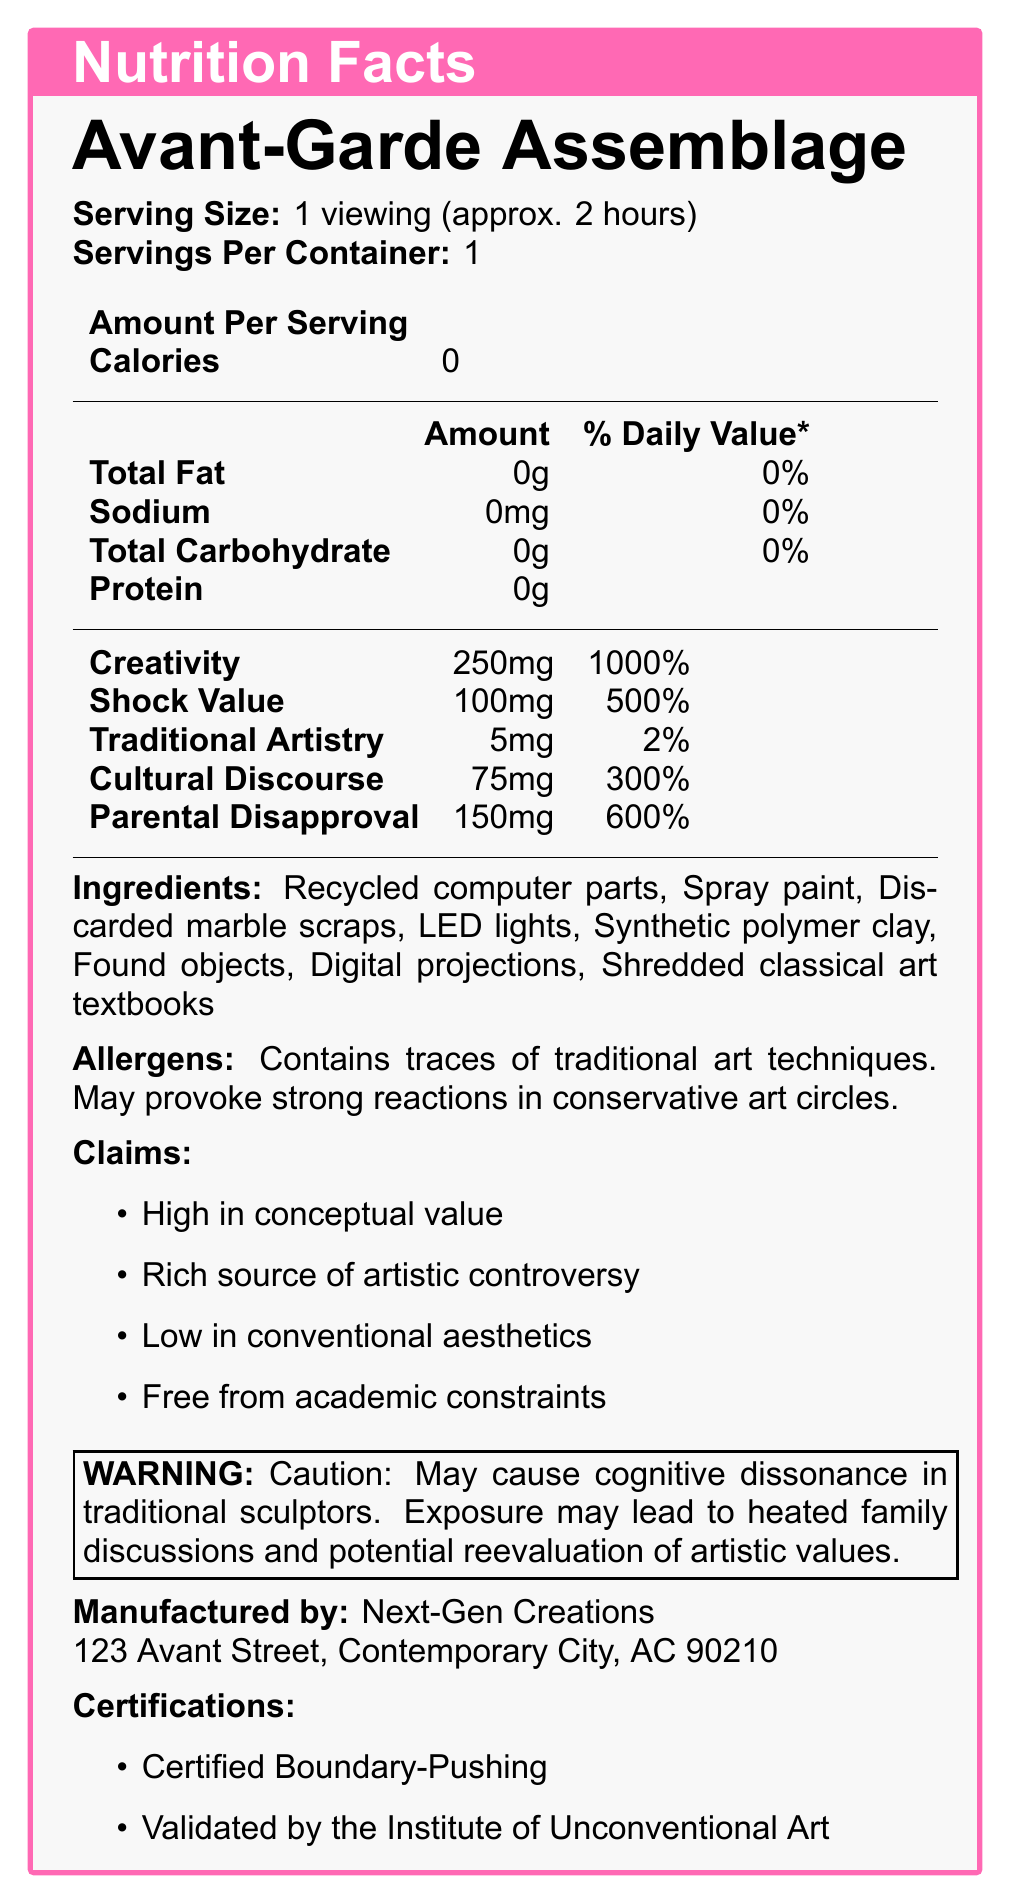What is the serving size of Avant-Garde Assemblage? The document specifies the serving size in the top section, indicating that a single viewing lasts approximately 2 hours.
Answer: 1 viewing (approx. 2 hours) Does the product contain any calories? The document lists "Calories: 0" in the nutrition facts section.
Answer: No How much Creativity does one serving of Avant-Garde Assemblage provide? According to the vitamins section of the nutrition facts, each serving contains 250mg of Creativity.
Answer: 250mg What is the manufacturer of Avant-Garde Assemblage? The manufacturer information at the bottom of the document states that it is made by Next-Gen Creations.
Answer: Next-Gen Creations Which ingredient is NOT included in Avant-Garde Assemblage? 
A. Found objects 
B. Traditional sculptures 
C. Shredded classical art textbooks The ingredients list includes Found objects and Shredded classical art textbooks, but not Traditional sculptures.
Answer: B What is one of the claims made about this product? The claims section lists several points, including "High in conceptual value."
Answer: High in conceptual value How might conservative art circles react to this product? The allergens section mentions that it may provoke strong reactions in conservative art circles.
Answer: May provoke strong reactions What’s the potential daily value percentage of Parental Disapproval provided by one serving? The minerals section of the nutrition facts indicates that Parental Disapproval stands at 600% of the daily value.
Answer: 600% True or False: The product is low in conventional aesthetics. One of the claims mentioned in the document is that the product is low in conventional aesthetics.
Answer: True Which statement is NOT part of the warning? 
i. May cause cognitive dissonance in traditional sculptors 
ii. Exposure may lead to reevaluation of artistic values 
iii. Not suitable for children under 12 The warning statement includes i and ii but does not mention anything about being unsuitable for children under 12.
Answer: iii Describe the main idea of this document. The document is structured as a satirical nutrition label for a conceptual art piece. It details the serving size, ingredients, and various abstract nutritional components such as Creativity, Shock Value, and Traditional Artistry. It also includes claims about the art’s impact, allergens, and humorous warnings about potential reactions, notably emphasizing the clash between traditional and modern artistic values.
Answer: The document presents the details of a conceptual art piece called "Avant-Garde Assemblage" with nutritional facts mimicking a food label, highlighting unconventional materials and their exaggerated "nutritional" impact, alongside various attributes, claims, and warnings. Does this document provide information on the cost of the product? The document does not include any details regarding the price or cost of the product.
Answer: No How much Traditional Artistry is included in one serving? The nutrition facts section lists Traditional Artistry at 5mg per serving.
Answer: 5mg What certifications has Avant-Garde Assemblage received? At the bottom of the document, it mentions two certifications: Certified Boundary-Pushing and Validated by the Institute of Unconventional Art.
Answer: Certified Boundary-Pushing, Validated by the Institute of Unconventional Art 